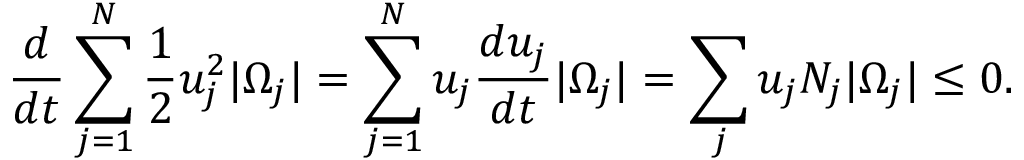<formula> <loc_0><loc_0><loc_500><loc_500>\frac { d } { d t } \sum _ { j = 1 } ^ { N } \frac { 1 } { 2 } u _ { j } ^ { 2 } | \Omega _ { j } | = \sum _ { j = 1 } ^ { N } u _ { j } \frac { d u _ { j } } { d t } | \Omega _ { j } | = \sum _ { j } u _ { j } N _ { j } | \Omega _ { j } | \leq 0 .</formula> 